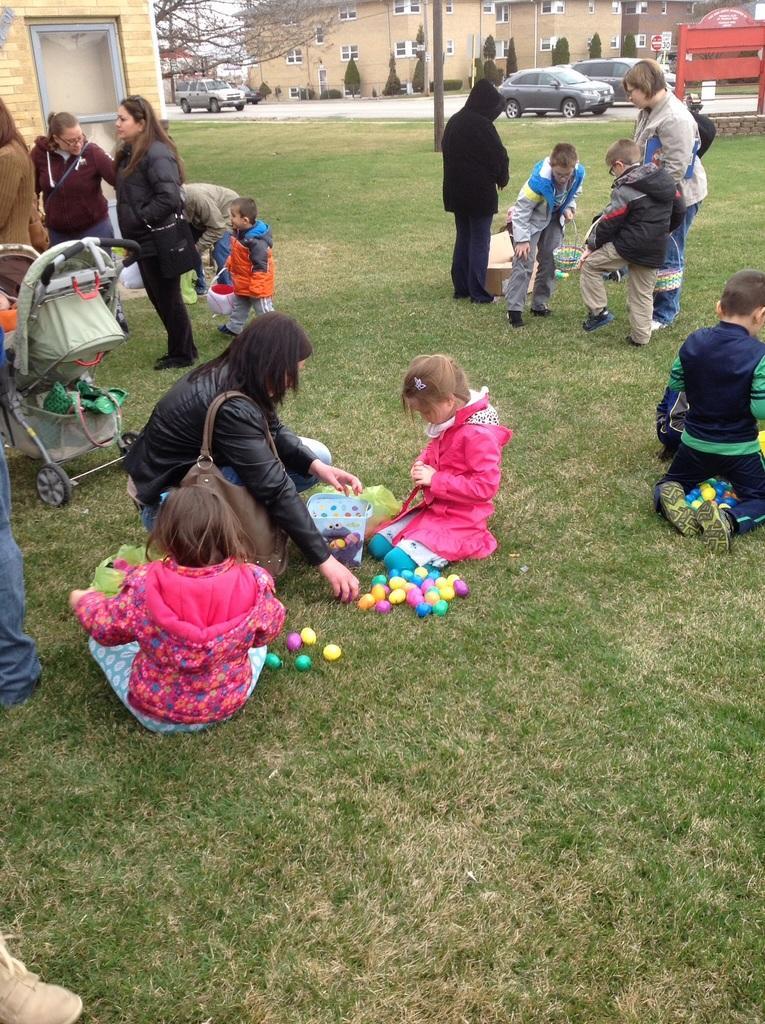Can you describe this image briefly? In this image there are a few people sitting and standing on the surface of the grass and there are a few objects and a baby walker. In the background there are buildings, trees and few vehicles moving on the road. 